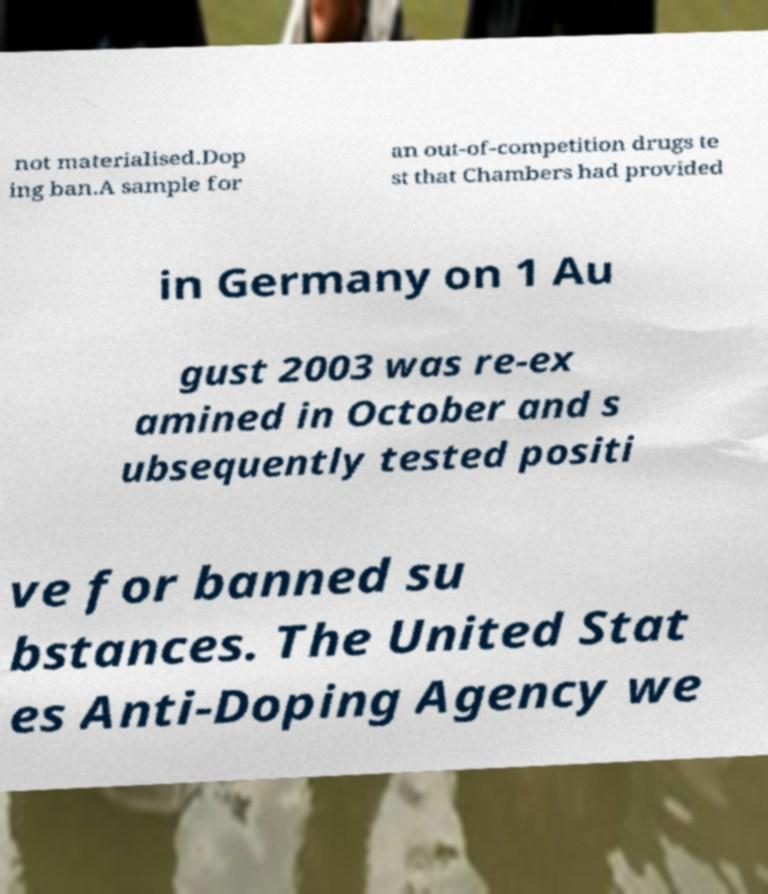I need the written content from this picture converted into text. Can you do that? not materialised.Dop ing ban.A sample for an out-of-competition drugs te st that Chambers had provided in Germany on 1 Au gust 2003 was re-ex amined in October and s ubsequently tested positi ve for banned su bstances. The United Stat es Anti-Doping Agency we 